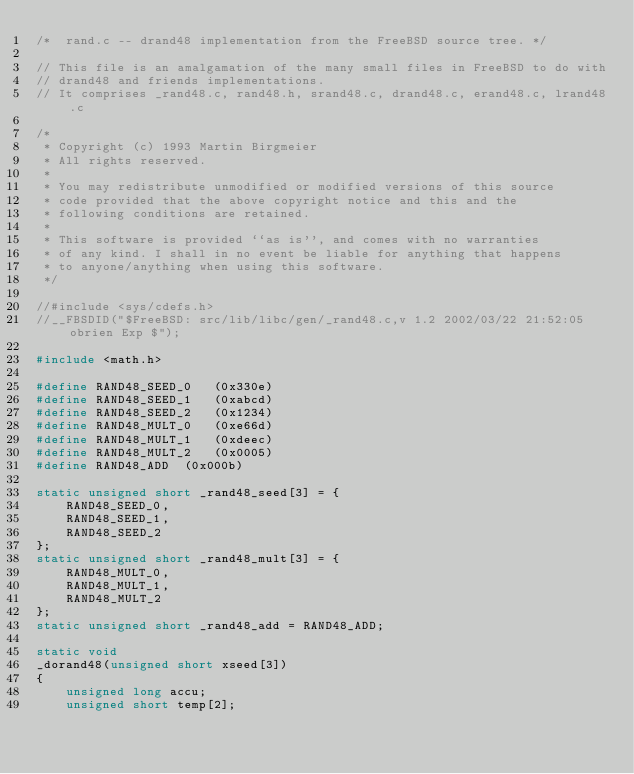Convert code to text. <code><loc_0><loc_0><loc_500><loc_500><_C_>/*  rand.c -- drand48 implementation from the FreeBSD source tree. */

// This file is an amalgamation of the many small files in FreeBSD to do with
// drand48 and friends implementations.
// It comprises _rand48.c, rand48.h, srand48.c, drand48.c, erand48.c, lrand48.c

/*
 * Copyright (c) 1993 Martin Birgmeier
 * All rights reserved.
 *
 * You may redistribute unmodified or modified versions of this source
 * code provided that the above copyright notice and this and the
 * following conditions are retained.
 *
 * This software is provided ``as is'', and comes with no warranties
 * of any kind. I shall in no event be liable for anything that happens
 * to anyone/anything when using this software.
 */

//#include <sys/cdefs.h>
//__FBSDID("$FreeBSD: src/lib/libc/gen/_rand48.c,v 1.2 2002/03/22 21:52:05 obrien Exp $");

#include <math.h>

#define	RAND48_SEED_0	(0x330e)
#define	RAND48_SEED_1	(0xabcd)
#define	RAND48_SEED_2	(0x1234)
#define	RAND48_MULT_0	(0xe66d)
#define	RAND48_MULT_1	(0xdeec)
#define	RAND48_MULT_2	(0x0005)
#define	RAND48_ADD	(0x000b)

static unsigned short _rand48_seed[3] = {
	RAND48_SEED_0,
	RAND48_SEED_1,
	RAND48_SEED_2
};
static unsigned short _rand48_mult[3] = {
	RAND48_MULT_0,
	RAND48_MULT_1,
	RAND48_MULT_2
};
static unsigned short _rand48_add = RAND48_ADD;

static void
_dorand48(unsigned short xseed[3])
{
	unsigned long accu;
	unsigned short temp[2];
</code> 